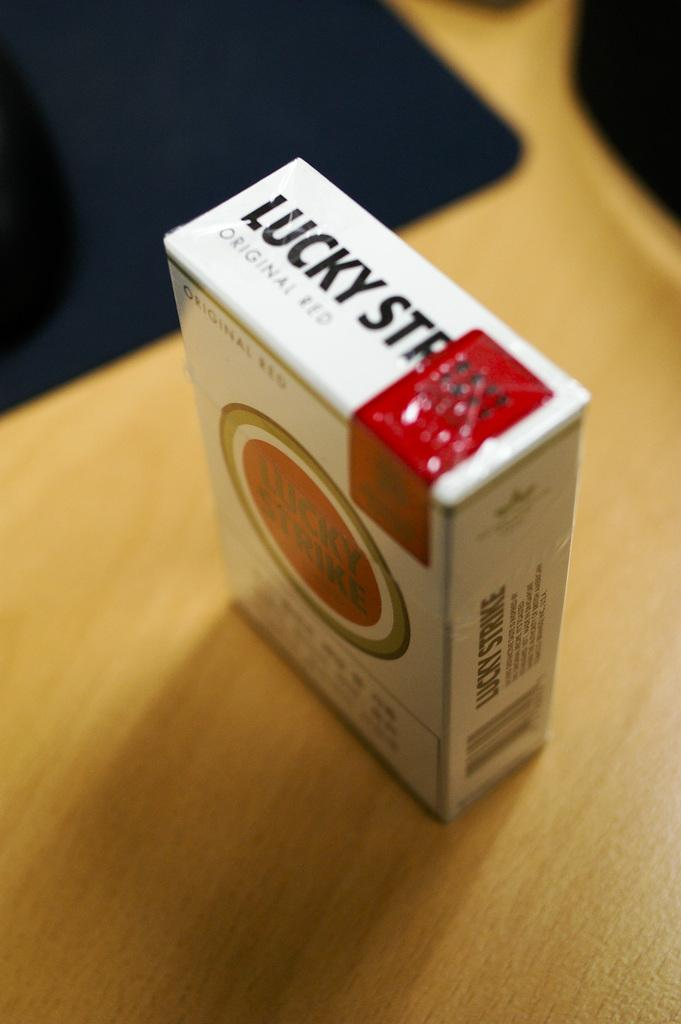<image>
Present a compact description of the photo's key features. A pack of Lucky Strikes sits on a wooden table. 